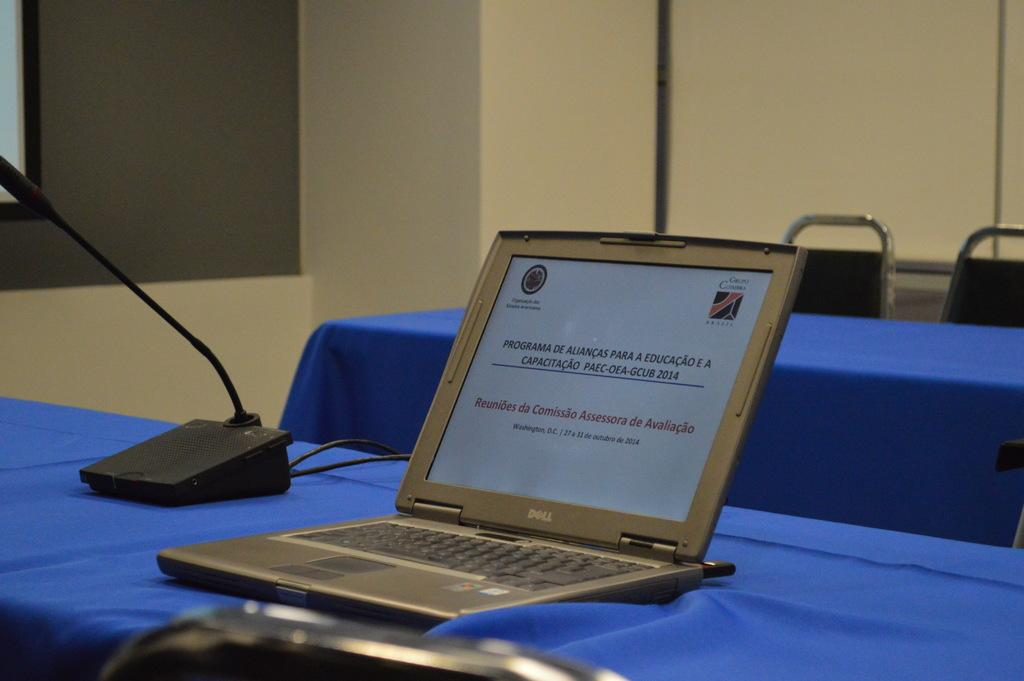<image>
Give a short and clear explanation of the subsequent image. An open Dell laptop and a black microphone on a stand on top of a table covered in blue. 